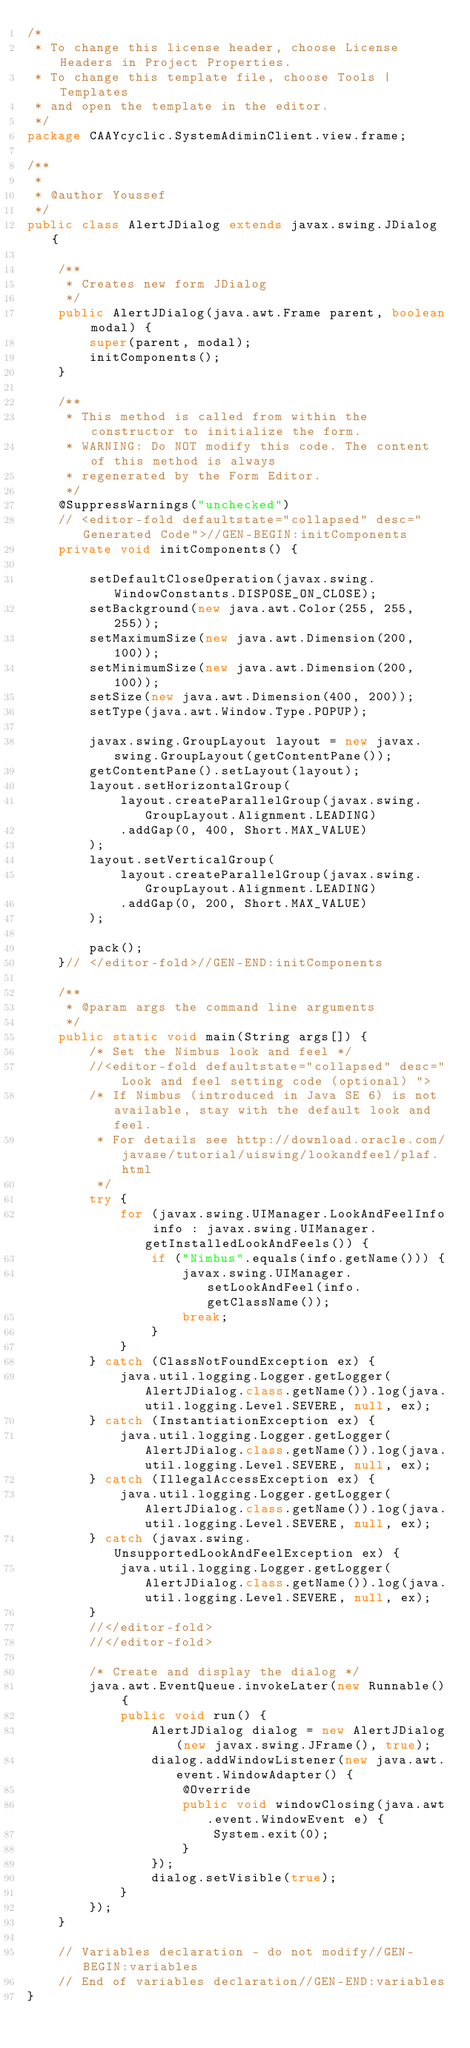Convert code to text. <code><loc_0><loc_0><loc_500><loc_500><_Java_>/*
 * To change this license header, choose License Headers in Project Properties.
 * To change this template file, choose Tools | Templates
 * and open the template in the editor.
 */
package CAAYcyclic.SystemAdiminClient.view.frame;

/**
 *
 * @author Youssef
 */
public class AlertJDialog extends javax.swing.JDialog {

    /**
     * Creates new form JDialog
     */
    public AlertJDialog(java.awt.Frame parent, boolean modal) {
        super(parent, modal);
        initComponents();
    }

    /**
     * This method is called from within the constructor to initialize the form.
     * WARNING: Do NOT modify this code. The content of this method is always
     * regenerated by the Form Editor.
     */
    @SuppressWarnings("unchecked")
    // <editor-fold defaultstate="collapsed" desc="Generated Code">//GEN-BEGIN:initComponents
    private void initComponents() {

        setDefaultCloseOperation(javax.swing.WindowConstants.DISPOSE_ON_CLOSE);
        setBackground(new java.awt.Color(255, 255, 255));
        setMaximumSize(new java.awt.Dimension(200, 100));
        setMinimumSize(new java.awt.Dimension(200, 100));
        setSize(new java.awt.Dimension(400, 200));
        setType(java.awt.Window.Type.POPUP);

        javax.swing.GroupLayout layout = new javax.swing.GroupLayout(getContentPane());
        getContentPane().setLayout(layout);
        layout.setHorizontalGroup(
            layout.createParallelGroup(javax.swing.GroupLayout.Alignment.LEADING)
            .addGap(0, 400, Short.MAX_VALUE)
        );
        layout.setVerticalGroup(
            layout.createParallelGroup(javax.swing.GroupLayout.Alignment.LEADING)
            .addGap(0, 200, Short.MAX_VALUE)
        );

        pack();
    }// </editor-fold>//GEN-END:initComponents

    /**
     * @param args the command line arguments
     */
    public static void main(String args[]) {
        /* Set the Nimbus look and feel */
        //<editor-fold defaultstate="collapsed" desc=" Look and feel setting code (optional) ">
        /* If Nimbus (introduced in Java SE 6) is not available, stay with the default look and feel.
         * For details see http://download.oracle.com/javase/tutorial/uiswing/lookandfeel/plaf.html 
         */
        try {
            for (javax.swing.UIManager.LookAndFeelInfo info : javax.swing.UIManager.getInstalledLookAndFeels()) {
                if ("Nimbus".equals(info.getName())) {
                    javax.swing.UIManager.setLookAndFeel(info.getClassName());
                    break;
                }
            }
        } catch (ClassNotFoundException ex) {
            java.util.logging.Logger.getLogger(AlertJDialog.class.getName()).log(java.util.logging.Level.SEVERE, null, ex);
        } catch (InstantiationException ex) {
            java.util.logging.Logger.getLogger(AlertJDialog.class.getName()).log(java.util.logging.Level.SEVERE, null, ex);
        } catch (IllegalAccessException ex) {
            java.util.logging.Logger.getLogger(AlertJDialog.class.getName()).log(java.util.logging.Level.SEVERE, null, ex);
        } catch (javax.swing.UnsupportedLookAndFeelException ex) {
            java.util.logging.Logger.getLogger(AlertJDialog.class.getName()).log(java.util.logging.Level.SEVERE, null, ex);
        }
        //</editor-fold>
        //</editor-fold>

        /* Create and display the dialog */
        java.awt.EventQueue.invokeLater(new Runnable() {
            public void run() {
                AlertJDialog dialog = new AlertJDialog(new javax.swing.JFrame(), true);
                dialog.addWindowListener(new java.awt.event.WindowAdapter() {
                    @Override
                    public void windowClosing(java.awt.event.WindowEvent e) {
                        System.exit(0);
                    }
                });
                dialog.setVisible(true);
            }
        });
    }

    // Variables declaration - do not modify//GEN-BEGIN:variables
    // End of variables declaration//GEN-END:variables
}
</code> 